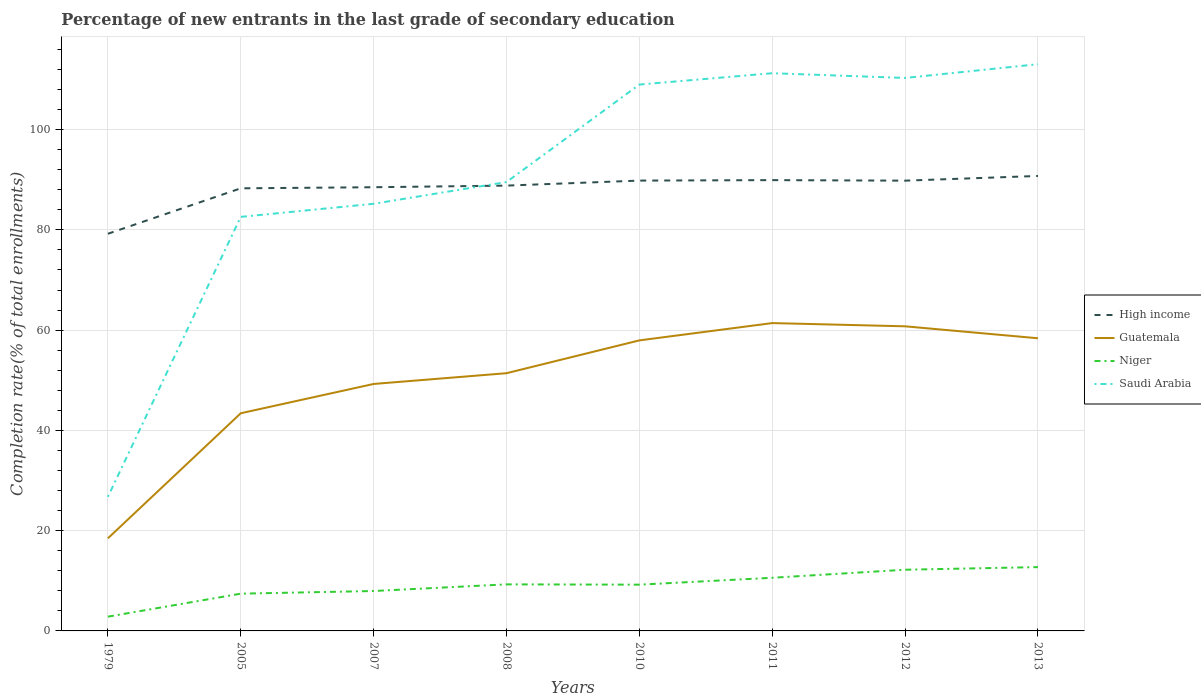Is the number of lines equal to the number of legend labels?
Keep it short and to the point. Yes. Across all years, what is the maximum percentage of new entrants in Saudi Arabia?
Offer a terse response. 26.76. In which year was the percentage of new entrants in Guatemala maximum?
Provide a short and direct response. 1979. What is the total percentage of new entrants in Saudi Arabia in the graph?
Offer a very short reply. -82.22. What is the difference between the highest and the second highest percentage of new entrants in Saudi Arabia?
Keep it short and to the point. 86.28. What is the difference between two consecutive major ticks on the Y-axis?
Make the answer very short. 20. Are the values on the major ticks of Y-axis written in scientific E-notation?
Offer a terse response. No. Does the graph contain grids?
Keep it short and to the point. Yes. How many legend labels are there?
Provide a short and direct response. 4. What is the title of the graph?
Provide a short and direct response. Percentage of new entrants in the last grade of secondary education. What is the label or title of the Y-axis?
Ensure brevity in your answer.  Completion rate(% of total enrollments). What is the Completion rate(% of total enrollments) in High income in 1979?
Offer a terse response. 79.22. What is the Completion rate(% of total enrollments) in Guatemala in 1979?
Keep it short and to the point. 18.47. What is the Completion rate(% of total enrollments) of Niger in 1979?
Make the answer very short. 2.85. What is the Completion rate(% of total enrollments) in Saudi Arabia in 1979?
Offer a terse response. 26.76. What is the Completion rate(% of total enrollments) in High income in 2005?
Your response must be concise. 88.28. What is the Completion rate(% of total enrollments) of Guatemala in 2005?
Keep it short and to the point. 43.42. What is the Completion rate(% of total enrollments) in Niger in 2005?
Provide a short and direct response. 7.43. What is the Completion rate(% of total enrollments) of Saudi Arabia in 2005?
Provide a succinct answer. 82.59. What is the Completion rate(% of total enrollments) of High income in 2007?
Your answer should be compact. 88.5. What is the Completion rate(% of total enrollments) in Guatemala in 2007?
Make the answer very short. 49.26. What is the Completion rate(% of total enrollments) in Niger in 2007?
Your answer should be very brief. 7.96. What is the Completion rate(% of total enrollments) in Saudi Arabia in 2007?
Your answer should be compact. 85.2. What is the Completion rate(% of total enrollments) in High income in 2008?
Keep it short and to the point. 88.82. What is the Completion rate(% of total enrollments) in Guatemala in 2008?
Keep it short and to the point. 51.41. What is the Completion rate(% of total enrollments) of Niger in 2008?
Ensure brevity in your answer.  9.29. What is the Completion rate(% of total enrollments) of Saudi Arabia in 2008?
Offer a terse response. 89.53. What is the Completion rate(% of total enrollments) in High income in 2010?
Make the answer very short. 89.82. What is the Completion rate(% of total enrollments) of Guatemala in 2010?
Offer a terse response. 57.95. What is the Completion rate(% of total enrollments) in Niger in 2010?
Provide a short and direct response. 9.23. What is the Completion rate(% of total enrollments) of Saudi Arabia in 2010?
Make the answer very short. 108.98. What is the Completion rate(% of total enrollments) of High income in 2011?
Offer a very short reply. 89.92. What is the Completion rate(% of total enrollments) of Guatemala in 2011?
Offer a very short reply. 61.4. What is the Completion rate(% of total enrollments) of Niger in 2011?
Make the answer very short. 10.6. What is the Completion rate(% of total enrollments) of Saudi Arabia in 2011?
Offer a very short reply. 111.24. What is the Completion rate(% of total enrollments) of High income in 2012?
Offer a terse response. 89.81. What is the Completion rate(% of total enrollments) of Guatemala in 2012?
Give a very brief answer. 60.76. What is the Completion rate(% of total enrollments) of Niger in 2012?
Ensure brevity in your answer.  12.21. What is the Completion rate(% of total enrollments) in Saudi Arabia in 2012?
Your response must be concise. 110.3. What is the Completion rate(% of total enrollments) in High income in 2013?
Your answer should be compact. 90.75. What is the Completion rate(% of total enrollments) of Guatemala in 2013?
Give a very brief answer. 58.37. What is the Completion rate(% of total enrollments) in Niger in 2013?
Make the answer very short. 12.73. What is the Completion rate(% of total enrollments) in Saudi Arabia in 2013?
Your answer should be compact. 113.04. Across all years, what is the maximum Completion rate(% of total enrollments) of High income?
Provide a short and direct response. 90.75. Across all years, what is the maximum Completion rate(% of total enrollments) of Guatemala?
Keep it short and to the point. 61.4. Across all years, what is the maximum Completion rate(% of total enrollments) of Niger?
Keep it short and to the point. 12.73. Across all years, what is the maximum Completion rate(% of total enrollments) in Saudi Arabia?
Your answer should be compact. 113.04. Across all years, what is the minimum Completion rate(% of total enrollments) of High income?
Provide a succinct answer. 79.22. Across all years, what is the minimum Completion rate(% of total enrollments) of Guatemala?
Offer a terse response. 18.47. Across all years, what is the minimum Completion rate(% of total enrollments) of Niger?
Offer a very short reply. 2.85. Across all years, what is the minimum Completion rate(% of total enrollments) in Saudi Arabia?
Give a very brief answer. 26.76. What is the total Completion rate(% of total enrollments) of High income in the graph?
Your answer should be compact. 705.13. What is the total Completion rate(% of total enrollments) in Guatemala in the graph?
Give a very brief answer. 401.04. What is the total Completion rate(% of total enrollments) of Niger in the graph?
Give a very brief answer. 72.29. What is the total Completion rate(% of total enrollments) in Saudi Arabia in the graph?
Your answer should be compact. 727.63. What is the difference between the Completion rate(% of total enrollments) in High income in 1979 and that in 2005?
Provide a succinct answer. -9.06. What is the difference between the Completion rate(% of total enrollments) of Guatemala in 1979 and that in 2005?
Offer a very short reply. -24.95. What is the difference between the Completion rate(% of total enrollments) of Niger in 1979 and that in 2005?
Keep it short and to the point. -4.59. What is the difference between the Completion rate(% of total enrollments) in Saudi Arabia in 1979 and that in 2005?
Provide a short and direct response. -55.83. What is the difference between the Completion rate(% of total enrollments) in High income in 1979 and that in 2007?
Give a very brief answer. -9.28. What is the difference between the Completion rate(% of total enrollments) in Guatemala in 1979 and that in 2007?
Make the answer very short. -30.79. What is the difference between the Completion rate(% of total enrollments) of Niger in 1979 and that in 2007?
Offer a terse response. -5.12. What is the difference between the Completion rate(% of total enrollments) of Saudi Arabia in 1979 and that in 2007?
Your answer should be compact. -58.44. What is the difference between the Completion rate(% of total enrollments) in High income in 1979 and that in 2008?
Your response must be concise. -9.6. What is the difference between the Completion rate(% of total enrollments) in Guatemala in 1979 and that in 2008?
Provide a succinct answer. -32.93. What is the difference between the Completion rate(% of total enrollments) of Niger in 1979 and that in 2008?
Offer a very short reply. -6.44. What is the difference between the Completion rate(% of total enrollments) of Saudi Arabia in 1979 and that in 2008?
Keep it short and to the point. -62.77. What is the difference between the Completion rate(% of total enrollments) in High income in 1979 and that in 2010?
Offer a terse response. -10.6. What is the difference between the Completion rate(% of total enrollments) of Guatemala in 1979 and that in 2010?
Ensure brevity in your answer.  -39.48. What is the difference between the Completion rate(% of total enrollments) of Niger in 1979 and that in 2010?
Give a very brief answer. -6.38. What is the difference between the Completion rate(% of total enrollments) of Saudi Arabia in 1979 and that in 2010?
Offer a terse response. -82.22. What is the difference between the Completion rate(% of total enrollments) in High income in 1979 and that in 2011?
Offer a very short reply. -10.7. What is the difference between the Completion rate(% of total enrollments) in Guatemala in 1979 and that in 2011?
Provide a short and direct response. -42.93. What is the difference between the Completion rate(% of total enrollments) of Niger in 1979 and that in 2011?
Your answer should be compact. -7.76. What is the difference between the Completion rate(% of total enrollments) in Saudi Arabia in 1979 and that in 2011?
Offer a very short reply. -84.48. What is the difference between the Completion rate(% of total enrollments) in High income in 1979 and that in 2012?
Offer a very short reply. -10.59. What is the difference between the Completion rate(% of total enrollments) of Guatemala in 1979 and that in 2012?
Provide a succinct answer. -42.29. What is the difference between the Completion rate(% of total enrollments) in Niger in 1979 and that in 2012?
Your answer should be very brief. -9.36. What is the difference between the Completion rate(% of total enrollments) in Saudi Arabia in 1979 and that in 2012?
Your response must be concise. -83.54. What is the difference between the Completion rate(% of total enrollments) in High income in 1979 and that in 2013?
Offer a terse response. -11.53. What is the difference between the Completion rate(% of total enrollments) of Guatemala in 1979 and that in 2013?
Ensure brevity in your answer.  -39.9. What is the difference between the Completion rate(% of total enrollments) in Niger in 1979 and that in 2013?
Your answer should be very brief. -9.88. What is the difference between the Completion rate(% of total enrollments) in Saudi Arabia in 1979 and that in 2013?
Ensure brevity in your answer.  -86.28. What is the difference between the Completion rate(% of total enrollments) in High income in 2005 and that in 2007?
Keep it short and to the point. -0.22. What is the difference between the Completion rate(% of total enrollments) of Guatemala in 2005 and that in 2007?
Ensure brevity in your answer.  -5.84. What is the difference between the Completion rate(% of total enrollments) in Niger in 2005 and that in 2007?
Provide a short and direct response. -0.53. What is the difference between the Completion rate(% of total enrollments) of Saudi Arabia in 2005 and that in 2007?
Provide a succinct answer. -2.61. What is the difference between the Completion rate(% of total enrollments) in High income in 2005 and that in 2008?
Provide a succinct answer. -0.54. What is the difference between the Completion rate(% of total enrollments) in Guatemala in 2005 and that in 2008?
Make the answer very short. -7.99. What is the difference between the Completion rate(% of total enrollments) in Niger in 2005 and that in 2008?
Provide a short and direct response. -1.85. What is the difference between the Completion rate(% of total enrollments) of Saudi Arabia in 2005 and that in 2008?
Provide a short and direct response. -6.95. What is the difference between the Completion rate(% of total enrollments) in High income in 2005 and that in 2010?
Ensure brevity in your answer.  -1.54. What is the difference between the Completion rate(% of total enrollments) in Guatemala in 2005 and that in 2010?
Make the answer very short. -14.53. What is the difference between the Completion rate(% of total enrollments) of Niger in 2005 and that in 2010?
Ensure brevity in your answer.  -1.8. What is the difference between the Completion rate(% of total enrollments) in Saudi Arabia in 2005 and that in 2010?
Provide a short and direct response. -26.39. What is the difference between the Completion rate(% of total enrollments) in High income in 2005 and that in 2011?
Provide a succinct answer. -1.63. What is the difference between the Completion rate(% of total enrollments) in Guatemala in 2005 and that in 2011?
Offer a very short reply. -17.99. What is the difference between the Completion rate(% of total enrollments) in Niger in 2005 and that in 2011?
Your answer should be compact. -3.17. What is the difference between the Completion rate(% of total enrollments) in Saudi Arabia in 2005 and that in 2011?
Keep it short and to the point. -28.65. What is the difference between the Completion rate(% of total enrollments) in High income in 2005 and that in 2012?
Make the answer very short. -1.53. What is the difference between the Completion rate(% of total enrollments) in Guatemala in 2005 and that in 2012?
Provide a short and direct response. -17.34. What is the difference between the Completion rate(% of total enrollments) of Niger in 2005 and that in 2012?
Offer a very short reply. -4.78. What is the difference between the Completion rate(% of total enrollments) in Saudi Arabia in 2005 and that in 2012?
Keep it short and to the point. -27.71. What is the difference between the Completion rate(% of total enrollments) in High income in 2005 and that in 2013?
Give a very brief answer. -2.47. What is the difference between the Completion rate(% of total enrollments) in Guatemala in 2005 and that in 2013?
Ensure brevity in your answer.  -14.96. What is the difference between the Completion rate(% of total enrollments) of Niger in 2005 and that in 2013?
Your answer should be very brief. -5.3. What is the difference between the Completion rate(% of total enrollments) in Saudi Arabia in 2005 and that in 2013?
Ensure brevity in your answer.  -30.45. What is the difference between the Completion rate(% of total enrollments) of High income in 2007 and that in 2008?
Provide a succinct answer. -0.32. What is the difference between the Completion rate(% of total enrollments) in Guatemala in 2007 and that in 2008?
Make the answer very short. -2.15. What is the difference between the Completion rate(% of total enrollments) in Niger in 2007 and that in 2008?
Give a very brief answer. -1.32. What is the difference between the Completion rate(% of total enrollments) of Saudi Arabia in 2007 and that in 2008?
Make the answer very short. -4.33. What is the difference between the Completion rate(% of total enrollments) of High income in 2007 and that in 2010?
Keep it short and to the point. -1.32. What is the difference between the Completion rate(% of total enrollments) in Guatemala in 2007 and that in 2010?
Ensure brevity in your answer.  -8.69. What is the difference between the Completion rate(% of total enrollments) of Niger in 2007 and that in 2010?
Provide a short and direct response. -1.27. What is the difference between the Completion rate(% of total enrollments) of Saudi Arabia in 2007 and that in 2010?
Your response must be concise. -23.78. What is the difference between the Completion rate(% of total enrollments) in High income in 2007 and that in 2011?
Offer a very short reply. -1.42. What is the difference between the Completion rate(% of total enrollments) in Guatemala in 2007 and that in 2011?
Your answer should be very brief. -12.14. What is the difference between the Completion rate(% of total enrollments) in Niger in 2007 and that in 2011?
Your answer should be compact. -2.64. What is the difference between the Completion rate(% of total enrollments) in Saudi Arabia in 2007 and that in 2011?
Make the answer very short. -26.04. What is the difference between the Completion rate(% of total enrollments) of High income in 2007 and that in 2012?
Provide a short and direct response. -1.31. What is the difference between the Completion rate(% of total enrollments) in Guatemala in 2007 and that in 2012?
Your answer should be compact. -11.5. What is the difference between the Completion rate(% of total enrollments) in Niger in 2007 and that in 2012?
Offer a terse response. -4.24. What is the difference between the Completion rate(% of total enrollments) in Saudi Arabia in 2007 and that in 2012?
Keep it short and to the point. -25.1. What is the difference between the Completion rate(% of total enrollments) in High income in 2007 and that in 2013?
Provide a succinct answer. -2.25. What is the difference between the Completion rate(% of total enrollments) of Guatemala in 2007 and that in 2013?
Your answer should be very brief. -9.11. What is the difference between the Completion rate(% of total enrollments) of Niger in 2007 and that in 2013?
Provide a succinct answer. -4.77. What is the difference between the Completion rate(% of total enrollments) in Saudi Arabia in 2007 and that in 2013?
Give a very brief answer. -27.84. What is the difference between the Completion rate(% of total enrollments) of High income in 2008 and that in 2010?
Ensure brevity in your answer.  -1. What is the difference between the Completion rate(% of total enrollments) of Guatemala in 2008 and that in 2010?
Ensure brevity in your answer.  -6.55. What is the difference between the Completion rate(% of total enrollments) in Niger in 2008 and that in 2010?
Your answer should be very brief. 0.06. What is the difference between the Completion rate(% of total enrollments) in Saudi Arabia in 2008 and that in 2010?
Offer a terse response. -19.44. What is the difference between the Completion rate(% of total enrollments) in High income in 2008 and that in 2011?
Make the answer very short. -1.09. What is the difference between the Completion rate(% of total enrollments) of Guatemala in 2008 and that in 2011?
Your response must be concise. -10. What is the difference between the Completion rate(% of total enrollments) of Niger in 2008 and that in 2011?
Ensure brevity in your answer.  -1.32. What is the difference between the Completion rate(% of total enrollments) of Saudi Arabia in 2008 and that in 2011?
Provide a short and direct response. -21.71. What is the difference between the Completion rate(% of total enrollments) in High income in 2008 and that in 2012?
Provide a short and direct response. -0.99. What is the difference between the Completion rate(% of total enrollments) of Guatemala in 2008 and that in 2012?
Make the answer very short. -9.35. What is the difference between the Completion rate(% of total enrollments) in Niger in 2008 and that in 2012?
Provide a succinct answer. -2.92. What is the difference between the Completion rate(% of total enrollments) in Saudi Arabia in 2008 and that in 2012?
Offer a terse response. -20.77. What is the difference between the Completion rate(% of total enrollments) in High income in 2008 and that in 2013?
Give a very brief answer. -1.93. What is the difference between the Completion rate(% of total enrollments) in Guatemala in 2008 and that in 2013?
Provide a short and direct response. -6.97. What is the difference between the Completion rate(% of total enrollments) in Niger in 2008 and that in 2013?
Your answer should be very brief. -3.44. What is the difference between the Completion rate(% of total enrollments) of Saudi Arabia in 2008 and that in 2013?
Keep it short and to the point. -23.51. What is the difference between the Completion rate(% of total enrollments) of High income in 2010 and that in 2011?
Provide a short and direct response. -0.09. What is the difference between the Completion rate(% of total enrollments) in Guatemala in 2010 and that in 2011?
Make the answer very short. -3.45. What is the difference between the Completion rate(% of total enrollments) of Niger in 2010 and that in 2011?
Your answer should be very brief. -1.37. What is the difference between the Completion rate(% of total enrollments) of Saudi Arabia in 2010 and that in 2011?
Your answer should be very brief. -2.27. What is the difference between the Completion rate(% of total enrollments) of High income in 2010 and that in 2012?
Your answer should be compact. 0.01. What is the difference between the Completion rate(% of total enrollments) in Guatemala in 2010 and that in 2012?
Your response must be concise. -2.81. What is the difference between the Completion rate(% of total enrollments) in Niger in 2010 and that in 2012?
Your answer should be very brief. -2.98. What is the difference between the Completion rate(% of total enrollments) of Saudi Arabia in 2010 and that in 2012?
Provide a succinct answer. -1.32. What is the difference between the Completion rate(% of total enrollments) of High income in 2010 and that in 2013?
Provide a short and direct response. -0.93. What is the difference between the Completion rate(% of total enrollments) in Guatemala in 2010 and that in 2013?
Your answer should be compact. -0.42. What is the difference between the Completion rate(% of total enrollments) of Niger in 2010 and that in 2013?
Offer a very short reply. -3.5. What is the difference between the Completion rate(% of total enrollments) in Saudi Arabia in 2010 and that in 2013?
Your answer should be very brief. -4.06. What is the difference between the Completion rate(% of total enrollments) in High income in 2011 and that in 2012?
Your answer should be very brief. 0.11. What is the difference between the Completion rate(% of total enrollments) in Guatemala in 2011 and that in 2012?
Your answer should be very brief. 0.64. What is the difference between the Completion rate(% of total enrollments) in Niger in 2011 and that in 2012?
Make the answer very short. -1.6. What is the difference between the Completion rate(% of total enrollments) in Saudi Arabia in 2011 and that in 2012?
Keep it short and to the point. 0.94. What is the difference between the Completion rate(% of total enrollments) in High income in 2011 and that in 2013?
Keep it short and to the point. -0.83. What is the difference between the Completion rate(% of total enrollments) in Guatemala in 2011 and that in 2013?
Ensure brevity in your answer.  3.03. What is the difference between the Completion rate(% of total enrollments) in Niger in 2011 and that in 2013?
Your answer should be compact. -2.13. What is the difference between the Completion rate(% of total enrollments) of Saudi Arabia in 2011 and that in 2013?
Ensure brevity in your answer.  -1.8. What is the difference between the Completion rate(% of total enrollments) of High income in 2012 and that in 2013?
Provide a succinct answer. -0.94. What is the difference between the Completion rate(% of total enrollments) of Guatemala in 2012 and that in 2013?
Make the answer very short. 2.38. What is the difference between the Completion rate(% of total enrollments) in Niger in 2012 and that in 2013?
Your answer should be very brief. -0.52. What is the difference between the Completion rate(% of total enrollments) of Saudi Arabia in 2012 and that in 2013?
Your answer should be compact. -2.74. What is the difference between the Completion rate(% of total enrollments) of High income in 1979 and the Completion rate(% of total enrollments) of Guatemala in 2005?
Give a very brief answer. 35.8. What is the difference between the Completion rate(% of total enrollments) of High income in 1979 and the Completion rate(% of total enrollments) of Niger in 2005?
Keep it short and to the point. 71.79. What is the difference between the Completion rate(% of total enrollments) of High income in 1979 and the Completion rate(% of total enrollments) of Saudi Arabia in 2005?
Ensure brevity in your answer.  -3.37. What is the difference between the Completion rate(% of total enrollments) in Guatemala in 1979 and the Completion rate(% of total enrollments) in Niger in 2005?
Offer a terse response. 11.04. What is the difference between the Completion rate(% of total enrollments) of Guatemala in 1979 and the Completion rate(% of total enrollments) of Saudi Arabia in 2005?
Your answer should be compact. -64.12. What is the difference between the Completion rate(% of total enrollments) in Niger in 1979 and the Completion rate(% of total enrollments) in Saudi Arabia in 2005?
Offer a very short reply. -79.74. What is the difference between the Completion rate(% of total enrollments) of High income in 1979 and the Completion rate(% of total enrollments) of Guatemala in 2007?
Your answer should be very brief. 29.96. What is the difference between the Completion rate(% of total enrollments) in High income in 1979 and the Completion rate(% of total enrollments) in Niger in 2007?
Provide a succinct answer. 71.26. What is the difference between the Completion rate(% of total enrollments) of High income in 1979 and the Completion rate(% of total enrollments) of Saudi Arabia in 2007?
Your response must be concise. -5.98. What is the difference between the Completion rate(% of total enrollments) of Guatemala in 1979 and the Completion rate(% of total enrollments) of Niger in 2007?
Keep it short and to the point. 10.51. What is the difference between the Completion rate(% of total enrollments) of Guatemala in 1979 and the Completion rate(% of total enrollments) of Saudi Arabia in 2007?
Make the answer very short. -66.73. What is the difference between the Completion rate(% of total enrollments) of Niger in 1979 and the Completion rate(% of total enrollments) of Saudi Arabia in 2007?
Your answer should be compact. -82.35. What is the difference between the Completion rate(% of total enrollments) in High income in 1979 and the Completion rate(% of total enrollments) in Guatemala in 2008?
Keep it short and to the point. 27.81. What is the difference between the Completion rate(% of total enrollments) of High income in 1979 and the Completion rate(% of total enrollments) of Niger in 2008?
Your response must be concise. 69.93. What is the difference between the Completion rate(% of total enrollments) of High income in 1979 and the Completion rate(% of total enrollments) of Saudi Arabia in 2008?
Provide a succinct answer. -10.31. What is the difference between the Completion rate(% of total enrollments) of Guatemala in 1979 and the Completion rate(% of total enrollments) of Niger in 2008?
Offer a terse response. 9.19. What is the difference between the Completion rate(% of total enrollments) of Guatemala in 1979 and the Completion rate(% of total enrollments) of Saudi Arabia in 2008?
Give a very brief answer. -71.06. What is the difference between the Completion rate(% of total enrollments) of Niger in 1979 and the Completion rate(% of total enrollments) of Saudi Arabia in 2008?
Provide a short and direct response. -86.69. What is the difference between the Completion rate(% of total enrollments) in High income in 1979 and the Completion rate(% of total enrollments) in Guatemala in 2010?
Make the answer very short. 21.27. What is the difference between the Completion rate(% of total enrollments) of High income in 1979 and the Completion rate(% of total enrollments) of Niger in 2010?
Your answer should be very brief. 69.99. What is the difference between the Completion rate(% of total enrollments) in High income in 1979 and the Completion rate(% of total enrollments) in Saudi Arabia in 2010?
Your answer should be very brief. -29.76. What is the difference between the Completion rate(% of total enrollments) of Guatemala in 1979 and the Completion rate(% of total enrollments) of Niger in 2010?
Ensure brevity in your answer.  9.24. What is the difference between the Completion rate(% of total enrollments) in Guatemala in 1979 and the Completion rate(% of total enrollments) in Saudi Arabia in 2010?
Offer a terse response. -90.5. What is the difference between the Completion rate(% of total enrollments) in Niger in 1979 and the Completion rate(% of total enrollments) in Saudi Arabia in 2010?
Provide a short and direct response. -106.13. What is the difference between the Completion rate(% of total enrollments) in High income in 1979 and the Completion rate(% of total enrollments) in Guatemala in 2011?
Give a very brief answer. 17.82. What is the difference between the Completion rate(% of total enrollments) in High income in 1979 and the Completion rate(% of total enrollments) in Niger in 2011?
Give a very brief answer. 68.62. What is the difference between the Completion rate(% of total enrollments) in High income in 1979 and the Completion rate(% of total enrollments) in Saudi Arabia in 2011?
Your response must be concise. -32.02. What is the difference between the Completion rate(% of total enrollments) of Guatemala in 1979 and the Completion rate(% of total enrollments) of Niger in 2011?
Your answer should be very brief. 7.87. What is the difference between the Completion rate(% of total enrollments) of Guatemala in 1979 and the Completion rate(% of total enrollments) of Saudi Arabia in 2011?
Keep it short and to the point. -92.77. What is the difference between the Completion rate(% of total enrollments) of Niger in 1979 and the Completion rate(% of total enrollments) of Saudi Arabia in 2011?
Ensure brevity in your answer.  -108.4. What is the difference between the Completion rate(% of total enrollments) in High income in 1979 and the Completion rate(% of total enrollments) in Guatemala in 2012?
Offer a terse response. 18.46. What is the difference between the Completion rate(% of total enrollments) of High income in 1979 and the Completion rate(% of total enrollments) of Niger in 2012?
Offer a terse response. 67.01. What is the difference between the Completion rate(% of total enrollments) of High income in 1979 and the Completion rate(% of total enrollments) of Saudi Arabia in 2012?
Offer a very short reply. -31.08. What is the difference between the Completion rate(% of total enrollments) of Guatemala in 1979 and the Completion rate(% of total enrollments) of Niger in 2012?
Keep it short and to the point. 6.27. What is the difference between the Completion rate(% of total enrollments) in Guatemala in 1979 and the Completion rate(% of total enrollments) in Saudi Arabia in 2012?
Ensure brevity in your answer.  -91.83. What is the difference between the Completion rate(% of total enrollments) of Niger in 1979 and the Completion rate(% of total enrollments) of Saudi Arabia in 2012?
Give a very brief answer. -107.45. What is the difference between the Completion rate(% of total enrollments) in High income in 1979 and the Completion rate(% of total enrollments) in Guatemala in 2013?
Provide a succinct answer. 20.85. What is the difference between the Completion rate(% of total enrollments) of High income in 1979 and the Completion rate(% of total enrollments) of Niger in 2013?
Provide a short and direct response. 66.49. What is the difference between the Completion rate(% of total enrollments) of High income in 1979 and the Completion rate(% of total enrollments) of Saudi Arabia in 2013?
Provide a succinct answer. -33.82. What is the difference between the Completion rate(% of total enrollments) of Guatemala in 1979 and the Completion rate(% of total enrollments) of Niger in 2013?
Your answer should be very brief. 5.74. What is the difference between the Completion rate(% of total enrollments) in Guatemala in 1979 and the Completion rate(% of total enrollments) in Saudi Arabia in 2013?
Your response must be concise. -94.57. What is the difference between the Completion rate(% of total enrollments) in Niger in 1979 and the Completion rate(% of total enrollments) in Saudi Arabia in 2013?
Offer a very short reply. -110.19. What is the difference between the Completion rate(% of total enrollments) in High income in 2005 and the Completion rate(% of total enrollments) in Guatemala in 2007?
Keep it short and to the point. 39.02. What is the difference between the Completion rate(% of total enrollments) of High income in 2005 and the Completion rate(% of total enrollments) of Niger in 2007?
Make the answer very short. 80.32. What is the difference between the Completion rate(% of total enrollments) in High income in 2005 and the Completion rate(% of total enrollments) in Saudi Arabia in 2007?
Your answer should be compact. 3.08. What is the difference between the Completion rate(% of total enrollments) of Guatemala in 2005 and the Completion rate(% of total enrollments) of Niger in 2007?
Offer a very short reply. 35.46. What is the difference between the Completion rate(% of total enrollments) of Guatemala in 2005 and the Completion rate(% of total enrollments) of Saudi Arabia in 2007?
Keep it short and to the point. -41.78. What is the difference between the Completion rate(% of total enrollments) of Niger in 2005 and the Completion rate(% of total enrollments) of Saudi Arabia in 2007?
Provide a succinct answer. -77.77. What is the difference between the Completion rate(% of total enrollments) in High income in 2005 and the Completion rate(% of total enrollments) in Guatemala in 2008?
Your response must be concise. 36.88. What is the difference between the Completion rate(% of total enrollments) of High income in 2005 and the Completion rate(% of total enrollments) of Niger in 2008?
Provide a short and direct response. 79. What is the difference between the Completion rate(% of total enrollments) of High income in 2005 and the Completion rate(% of total enrollments) of Saudi Arabia in 2008?
Offer a very short reply. -1.25. What is the difference between the Completion rate(% of total enrollments) of Guatemala in 2005 and the Completion rate(% of total enrollments) of Niger in 2008?
Your answer should be very brief. 34.13. What is the difference between the Completion rate(% of total enrollments) of Guatemala in 2005 and the Completion rate(% of total enrollments) of Saudi Arabia in 2008?
Give a very brief answer. -46.12. What is the difference between the Completion rate(% of total enrollments) in Niger in 2005 and the Completion rate(% of total enrollments) in Saudi Arabia in 2008?
Your answer should be very brief. -82.1. What is the difference between the Completion rate(% of total enrollments) in High income in 2005 and the Completion rate(% of total enrollments) in Guatemala in 2010?
Keep it short and to the point. 30.33. What is the difference between the Completion rate(% of total enrollments) in High income in 2005 and the Completion rate(% of total enrollments) in Niger in 2010?
Offer a terse response. 79.06. What is the difference between the Completion rate(% of total enrollments) of High income in 2005 and the Completion rate(% of total enrollments) of Saudi Arabia in 2010?
Your response must be concise. -20.69. What is the difference between the Completion rate(% of total enrollments) in Guatemala in 2005 and the Completion rate(% of total enrollments) in Niger in 2010?
Ensure brevity in your answer.  34.19. What is the difference between the Completion rate(% of total enrollments) of Guatemala in 2005 and the Completion rate(% of total enrollments) of Saudi Arabia in 2010?
Offer a terse response. -65.56. What is the difference between the Completion rate(% of total enrollments) of Niger in 2005 and the Completion rate(% of total enrollments) of Saudi Arabia in 2010?
Your answer should be compact. -101.54. What is the difference between the Completion rate(% of total enrollments) of High income in 2005 and the Completion rate(% of total enrollments) of Guatemala in 2011?
Your response must be concise. 26.88. What is the difference between the Completion rate(% of total enrollments) of High income in 2005 and the Completion rate(% of total enrollments) of Niger in 2011?
Offer a terse response. 77.68. What is the difference between the Completion rate(% of total enrollments) of High income in 2005 and the Completion rate(% of total enrollments) of Saudi Arabia in 2011?
Offer a very short reply. -22.96. What is the difference between the Completion rate(% of total enrollments) in Guatemala in 2005 and the Completion rate(% of total enrollments) in Niger in 2011?
Offer a very short reply. 32.82. What is the difference between the Completion rate(% of total enrollments) in Guatemala in 2005 and the Completion rate(% of total enrollments) in Saudi Arabia in 2011?
Your answer should be compact. -67.82. What is the difference between the Completion rate(% of total enrollments) of Niger in 2005 and the Completion rate(% of total enrollments) of Saudi Arabia in 2011?
Ensure brevity in your answer.  -103.81. What is the difference between the Completion rate(% of total enrollments) in High income in 2005 and the Completion rate(% of total enrollments) in Guatemala in 2012?
Ensure brevity in your answer.  27.53. What is the difference between the Completion rate(% of total enrollments) in High income in 2005 and the Completion rate(% of total enrollments) in Niger in 2012?
Your answer should be very brief. 76.08. What is the difference between the Completion rate(% of total enrollments) of High income in 2005 and the Completion rate(% of total enrollments) of Saudi Arabia in 2012?
Offer a very short reply. -22.01. What is the difference between the Completion rate(% of total enrollments) in Guatemala in 2005 and the Completion rate(% of total enrollments) in Niger in 2012?
Offer a very short reply. 31.21. What is the difference between the Completion rate(% of total enrollments) of Guatemala in 2005 and the Completion rate(% of total enrollments) of Saudi Arabia in 2012?
Your answer should be very brief. -66.88. What is the difference between the Completion rate(% of total enrollments) in Niger in 2005 and the Completion rate(% of total enrollments) in Saudi Arabia in 2012?
Give a very brief answer. -102.87. What is the difference between the Completion rate(% of total enrollments) in High income in 2005 and the Completion rate(% of total enrollments) in Guatemala in 2013?
Your answer should be very brief. 29.91. What is the difference between the Completion rate(% of total enrollments) in High income in 2005 and the Completion rate(% of total enrollments) in Niger in 2013?
Provide a succinct answer. 75.56. What is the difference between the Completion rate(% of total enrollments) of High income in 2005 and the Completion rate(% of total enrollments) of Saudi Arabia in 2013?
Offer a very short reply. -24.76. What is the difference between the Completion rate(% of total enrollments) in Guatemala in 2005 and the Completion rate(% of total enrollments) in Niger in 2013?
Keep it short and to the point. 30.69. What is the difference between the Completion rate(% of total enrollments) of Guatemala in 2005 and the Completion rate(% of total enrollments) of Saudi Arabia in 2013?
Keep it short and to the point. -69.62. What is the difference between the Completion rate(% of total enrollments) of Niger in 2005 and the Completion rate(% of total enrollments) of Saudi Arabia in 2013?
Your response must be concise. -105.61. What is the difference between the Completion rate(% of total enrollments) of High income in 2007 and the Completion rate(% of total enrollments) of Guatemala in 2008?
Keep it short and to the point. 37.09. What is the difference between the Completion rate(% of total enrollments) in High income in 2007 and the Completion rate(% of total enrollments) in Niger in 2008?
Ensure brevity in your answer.  79.22. What is the difference between the Completion rate(% of total enrollments) in High income in 2007 and the Completion rate(% of total enrollments) in Saudi Arabia in 2008?
Ensure brevity in your answer.  -1.03. What is the difference between the Completion rate(% of total enrollments) of Guatemala in 2007 and the Completion rate(% of total enrollments) of Niger in 2008?
Make the answer very short. 39.97. What is the difference between the Completion rate(% of total enrollments) of Guatemala in 2007 and the Completion rate(% of total enrollments) of Saudi Arabia in 2008?
Provide a succinct answer. -40.27. What is the difference between the Completion rate(% of total enrollments) of Niger in 2007 and the Completion rate(% of total enrollments) of Saudi Arabia in 2008?
Give a very brief answer. -81.57. What is the difference between the Completion rate(% of total enrollments) in High income in 2007 and the Completion rate(% of total enrollments) in Guatemala in 2010?
Make the answer very short. 30.55. What is the difference between the Completion rate(% of total enrollments) in High income in 2007 and the Completion rate(% of total enrollments) in Niger in 2010?
Your answer should be compact. 79.27. What is the difference between the Completion rate(% of total enrollments) in High income in 2007 and the Completion rate(% of total enrollments) in Saudi Arabia in 2010?
Offer a very short reply. -20.48. What is the difference between the Completion rate(% of total enrollments) of Guatemala in 2007 and the Completion rate(% of total enrollments) of Niger in 2010?
Offer a very short reply. 40.03. What is the difference between the Completion rate(% of total enrollments) in Guatemala in 2007 and the Completion rate(% of total enrollments) in Saudi Arabia in 2010?
Provide a short and direct response. -59.72. What is the difference between the Completion rate(% of total enrollments) in Niger in 2007 and the Completion rate(% of total enrollments) in Saudi Arabia in 2010?
Keep it short and to the point. -101.01. What is the difference between the Completion rate(% of total enrollments) in High income in 2007 and the Completion rate(% of total enrollments) in Guatemala in 2011?
Offer a very short reply. 27.1. What is the difference between the Completion rate(% of total enrollments) of High income in 2007 and the Completion rate(% of total enrollments) of Niger in 2011?
Your response must be concise. 77.9. What is the difference between the Completion rate(% of total enrollments) of High income in 2007 and the Completion rate(% of total enrollments) of Saudi Arabia in 2011?
Give a very brief answer. -22.74. What is the difference between the Completion rate(% of total enrollments) in Guatemala in 2007 and the Completion rate(% of total enrollments) in Niger in 2011?
Your answer should be compact. 38.66. What is the difference between the Completion rate(% of total enrollments) of Guatemala in 2007 and the Completion rate(% of total enrollments) of Saudi Arabia in 2011?
Make the answer very short. -61.98. What is the difference between the Completion rate(% of total enrollments) in Niger in 2007 and the Completion rate(% of total enrollments) in Saudi Arabia in 2011?
Keep it short and to the point. -103.28. What is the difference between the Completion rate(% of total enrollments) of High income in 2007 and the Completion rate(% of total enrollments) of Guatemala in 2012?
Your response must be concise. 27.74. What is the difference between the Completion rate(% of total enrollments) in High income in 2007 and the Completion rate(% of total enrollments) in Niger in 2012?
Offer a very short reply. 76.29. What is the difference between the Completion rate(% of total enrollments) in High income in 2007 and the Completion rate(% of total enrollments) in Saudi Arabia in 2012?
Your answer should be very brief. -21.8. What is the difference between the Completion rate(% of total enrollments) of Guatemala in 2007 and the Completion rate(% of total enrollments) of Niger in 2012?
Your answer should be very brief. 37.05. What is the difference between the Completion rate(% of total enrollments) of Guatemala in 2007 and the Completion rate(% of total enrollments) of Saudi Arabia in 2012?
Your answer should be very brief. -61.04. What is the difference between the Completion rate(% of total enrollments) of Niger in 2007 and the Completion rate(% of total enrollments) of Saudi Arabia in 2012?
Your answer should be compact. -102.34. What is the difference between the Completion rate(% of total enrollments) of High income in 2007 and the Completion rate(% of total enrollments) of Guatemala in 2013?
Offer a very short reply. 30.13. What is the difference between the Completion rate(% of total enrollments) in High income in 2007 and the Completion rate(% of total enrollments) in Niger in 2013?
Give a very brief answer. 75.77. What is the difference between the Completion rate(% of total enrollments) in High income in 2007 and the Completion rate(% of total enrollments) in Saudi Arabia in 2013?
Provide a succinct answer. -24.54. What is the difference between the Completion rate(% of total enrollments) of Guatemala in 2007 and the Completion rate(% of total enrollments) of Niger in 2013?
Offer a very short reply. 36.53. What is the difference between the Completion rate(% of total enrollments) in Guatemala in 2007 and the Completion rate(% of total enrollments) in Saudi Arabia in 2013?
Ensure brevity in your answer.  -63.78. What is the difference between the Completion rate(% of total enrollments) of Niger in 2007 and the Completion rate(% of total enrollments) of Saudi Arabia in 2013?
Provide a succinct answer. -105.08. What is the difference between the Completion rate(% of total enrollments) of High income in 2008 and the Completion rate(% of total enrollments) of Guatemala in 2010?
Provide a short and direct response. 30.87. What is the difference between the Completion rate(% of total enrollments) of High income in 2008 and the Completion rate(% of total enrollments) of Niger in 2010?
Provide a succinct answer. 79.6. What is the difference between the Completion rate(% of total enrollments) of High income in 2008 and the Completion rate(% of total enrollments) of Saudi Arabia in 2010?
Ensure brevity in your answer.  -20.15. What is the difference between the Completion rate(% of total enrollments) of Guatemala in 2008 and the Completion rate(% of total enrollments) of Niger in 2010?
Offer a very short reply. 42.18. What is the difference between the Completion rate(% of total enrollments) in Guatemala in 2008 and the Completion rate(% of total enrollments) in Saudi Arabia in 2010?
Your response must be concise. -57.57. What is the difference between the Completion rate(% of total enrollments) of Niger in 2008 and the Completion rate(% of total enrollments) of Saudi Arabia in 2010?
Make the answer very short. -99.69. What is the difference between the Completion rate(% of total enrollments) in High income in 2008 and the Completion rate(% of total enrollments) in Guatemala in 2011?
Give a very brief answer. 27.42. What is the difference between the Completion rate(% of total enrollments) in High income in 2008 and the Completion rate(% of total enrollments) in Niger in 2011?
Provide a succinct answer. 78.22. What is the difference between the Completion rate(% of total enrollments) of High income in 2008 and the Completion rate(% of total enrollments) of Saudi Arabia in 2011?
Keep it short and to the point. -22.42. What is the difference between the Completion rate(% of total enrollments) in Guatemala in 2008 and the Completion rate(% of total enrollments) in Niger in 2011?
Ensure brevity in your answer.  40.8. What is the difference between the Completion rate(% of total enrollments) of Guatemala in 2008 and the Completion rate(% of total enrollments) of Saudi Arabia in 2011?
Your response must be concise. -59.84. What is the difference between the Completion rate(% of total enrollments) of Niger in 2008 and the Completion rate(% of total enrollments) of Saudi Arabia in 2011?
Your response must be concise. -101.96. What is the difference between the Completion rate(% of total enrollments) of High income in 2008 and the Completion rate(% of total enrollments) of Guatemala in 2012?
Your answer should be very brief. 28.06. What is the difference between the Completion rate(% of total enrollments) in High income in 2008 and the Completion rate(% of total enrollments) in Niger in 2012?
Your response must be concise. 76.62. What is the difference between the Completion rate(% of total enrollments) of High income in 2008 and the Completion rate(% of total enrollments) of Saudi Arabia in 2012?
Your answer should be compact. -21.48. What is the difference between the Completion rate(% of total enrollments) of Guatemala in 2008 and the Completion rate(% of total enrollments) of Niger in 2012?
Your response must be concise. 39.2. What is the difference between the Completion rate(% of total enrollments) of Guatemala in 2008 and the Completion rate(% of total enrollments) of Saudi Arabia in 2012?
Your answer should be very brief. -58.89. What is the difference between the Completion rate(% of total enrollments) of Niger in 2008 and the Completion rate(% of total enrollments) of Saudi Arabia in 2012?
Make the answer very short. -101.01. What is the difference between the Completion rate(% of total enrollments) in High income in 2008 and the Completion rate(% of total enrollments) in Guatemala in 2013?
Provide a succinct answer. 30.45. What is the difference between the Completion rate(% of total enrollments) in High income in 2008 and the Completion rate(% of total enrollments) in Niger in 2013?
Keep it short and to the point. 76.09. What is the difference between the Completion rate(% of total enrollments) of High income in 2008 and the Completion rate(% of total enrollments) of Saudi Arabia in 2013?
Your response must be concise. -24.22. What is the difference between the Completion rate(% of total enrollments) of Guatemala in 2008 and the Completion rate(% of total enrollments) of Niger in 2013?
Keep it short and to the point. 38.68. What is the difference between the Completion rate(% of total enrollments) of Guatemala in 2008 and the Completion rate(% of total enrollments) of Saudi Arabia in 2013?
Keep it short and to the point. -61.63. What is the difference between the Completion rate(% of total enrollments) in Niger in 2008 and the Completion rate(% of total enrollments) in Saudi Arabia in 2013?
Provide a succinct answer. -103.75. What is the difference between the Completion rate(% of total enrollments) in High income in 2010 and the Completion rate(% of total enrollments) in Guatemala in 2011?
Give a very brief answer. 28.42. What is the difference between the Completion rate(% of total enrollments) of High income in 2010 and the Completion rate(% of total enrollments) of Niger in 2011?
Keep it short and to the point. 79.22. What is the difference between the Completion rate(% of total enrollments) in High income in 2010 and the Completion rate(% of total enrollments) in Saudi Arabia in 2011?
Give a very brief answer. -21.42. What is the difference between the Completion rate(% of total enrollments) in Guatemala in 2010 and the Completion rate(% of total enrollments) in Niger in 2011?
Provide a short and direct response. 47.35. What is the difference between the Completion rate(% of total enrollments) of Guatemala in 2010 and the Completion rate(% of total enrollments) of Saudi Arabia in 2011?
Keep it short and to the point. -53.29. What is the difference between the Completion rate(% of total enrollments) of Niger in 2010 and the Completion rate(% of total enrollments) of Saudi Arabia in 2011?
Ensure brevity in your answer.  -102.01. What is the difference between the Completion rate(% of total enrollments) of High income in 2010 and the Completion rate(% of total enrollments) of Guatemala in 2012?
Keep it short and to the point. 29.07. What is the difference between the Completion rate(% of total enrollments) in High income in 2010 and the Completion rate(% of total enrollments) in Niger in 2012?
Make the answer very short. 77.62. What is the difference between the Completion rate(% of total enrollments) in High income in 2010 and the Completion rate(% of total enrollments) in Saudi Arabia in 2012?
Give a very brief answer. -20.47. What is the difference between the Completion rate(% of total enrollments) of Guatemala in 2010 and the Completion rate(% of total enrollments) of Niger in 2012?
Offer a very short reply. 45.75. What is the difference between the Completion rate(% of total enrollments) in Guatemala in 2010 and the Completion rate(% of total enrollments) in Saudi Arabia in 2012?
Provide a short and direct response. -52.35. What is the difference between the Completion rate(% of total enrollments) of Niger in 2010 and the Completion rate(% of total enrollments) of Saudi Arabia in 2012?
Your answer should be compact. -101.07. What is the difference between the Completion rate(% of total enrollments) in High income in 2010 and the Completion rate(% of total enrollments) in Guatemala in 2013?
Provide a succinct answer. 31.45. What is the difference between the Completion rate(% of total enrollments) of High income in 2010 and the Completion rate(% of total enrollments) of Niger in 2013?
Your answer should be compact. 77.1. What is the difference between the Completion rate(% of total enrollments) in High income in 2010 and the Completion rate(% of total enrollments) in Saudi Arabia in 2013?
Offer a terse response. -23.22. What is the difference between the Completion rate(% of total enrollments) of Guatemala in 2010 and the Completion rate(% of total enrollments) of Niger in 2013?
Provide a succinct answer. 45.22. What is the difference between the Completion rate(% of total enrollments) of Guatemala in 2010 and the Completion rate(% of total enrollments) of Saudi Arabia in 2013?
Ensure brevity in your answer.  -55.09. What is the difference between the Completion rate(% of total enrollments) of Niger in 2010 and the Completion rate(% of total enrollments) of Saudi Arabia in 2013?
Provide a succinct answer. -103.81. What is the difference between the Completion rate(% of total enrollments) of High income in 2011 and the Completion rate(% of total enrollments) of Guatemala in 2012?
Make the answer very short. 29.16. What is the difference between the Completion rate(% of total enrollments) of High income in 2011 and the Completion rate(% of total enrollments) of Niger in 2012?
Your answer should be very brief. 77.71. What is the difference between the Completion rate(% of total enrollments) of High income in 2011 and the Completion rate(% of total enrollments) of Saudi Arabia in 2012?
Your response must be concise. -20.38. What is the difference between the Completion rate(% of total enrollments) of Guatemala in 2011 and the Completion rate(% of total enrollments) of Niger in 2012?
Offer a terse response. 49.2. What is the difference between the Completion rate(% of total enrollments) in Guatemala in 2011 and the Completion rate(% of total enrollments) in Saudi Arabia in 2012?
Give a very brief answer. -48.9. What is the difference between the Completion rate(% of total enrollments) of Niger in 2011 and the Completion rate(% of total enrollments) of Saudi Arabia in 2012?
Offer a terse response. -99.7. What is the difference between the Completion rate(% of total enrollments) of High income in 2011 and the Completion rate(% of total enrollments) of Guatemala in 2013?
Offer a terse response. 31.54. What is the difference between the Completion rate(% of total enrollments) in High income in 2011 and the Completion rate(% of total enrollments) in Niger in 2013?
Your response must be concise. 77.19. What is the difference between the Completion rate(% of total enrollments) in High income in 2011 and the Completion rate(% of total enrollments) in Saudi Arabia in 2013?
Provide a succinct answer. -23.12. What is the difference between the Completion rate(% of total enrollments) of Guatemala in 2011 and the Completion rate(% of total enrollments) of Niger in 2013?
Offer a terse response. 48.67. What is the difference between the Completion rate(% of total enrollments) in Guatemala in 2011 and the Completion rate(% of total enrollments) in Saudi Arabia in 2013?
Make the answer very short. -51.64. What is the difference between the Completion rate(% of total enrollments) in Niger in 2011 and the Completion rate(% of total enrollments) in Saudi Arabia in 2013?
Provide a succinct answer. -102.44. What is the difference between the Completion rate(% of total enrollments) in High income in 2012 and the Completion rate(% of total enrollments) in Guatemala in 2013?
Your answer should be very brief. 31.44. What is the difference between the Completion rate(% of total enrollments) of High income in 2012 and the Completion rate(% of total enrollments) of Niger in 2013?
Offer a very short reply. 77.08. What is the difference between the Completion rate(% of total enrollments) in High income in 2012 and the Completion rate(% of total enrollments) in Saudi Arabia in 2013?
Your response must be concise. -23.23. What is the difference between the Completion rate(% of total enrollments) in Guatemala in 2012 and the Completion rate(% of total enrollments) in Niger in 2013?
Ensure brevity in your answer.  48.03. What is the difference between the Completion rate(% of total enrollments) in Guatemala in 2012 and the Completion rate(% of total enrollments) in Saudi Arabia in 2013?
Provide a short and direct response. -52.28. What is the difference between the Completion rate(% of total enrollments) of Niger in 2012 and the Completion rate(% of total enrollments) of Saudi Arabia in 2013?
Offer a very short reply. -100.83. What is the average Completion rate(% of total enrollments) of High income per year?
Keep it short and to the point. 88.14. What is the average Completion rate(% of total enrollments) in Guatemala per year?
Provide a succinct answer. 50.13. What is the average Completion rate(% of total enrollments) of Niger per year?
Offer a terse response. 9.04. What is the average Completion rate(% of total enrollments) of Saudi Arabia per year?
Provide a succinct answer. 90.95. In the year 1979, what is the difference between the Completion rate(% of total enrollments) of High income and Completion rate(% of total enrollments) of Guatemala?
Ensure brevity in your answer.  60.75. In the year 1979, what is the difference between the Completion rate(% of total enrollments) of High income and Completion rate(% of total enrollments) of Niger?
Your answer should be very brief. 76.37. In the year 1979, what is the difference between the Completion rate(% of total enrollments) in High income and Completion rate(% of total enrollments) in Saudi Arabia?
Keep it short and to the point. 52.46. In the year 1979, what is the difference between the Completion rate(% of total enrollments) of Guatemala and Completion rate(% of total enrollments) of Niger?
Your answer should be very brief. 15.63. In the year 1979, what is the difference between the Completion rate(% of total enrollments) in Guatemala and Completion rate(% of total enrollments) in Saudi Arabia?
Offer a very short reply. -8.29. In the year 1979, what is the difference between the Completion rate(% of total enrollments) of Niger and Completion rate(% of total enrollments) of Saudi Arabia?
Offer a terse response. -23.91. In the year 2005, what is the difference between the Completion rate(% of total enrollments) in High income and Completion rate(% of total enrollments) in Guatemala?
Make the answer very short. 44.87. In the year 2005, what is the difference between the Completion rate(% of total enrollments) of High income and Completion rate(% of total enrollments) of Niger?
Offer a terse response. 80.85. In the year 2005, what is the difference between the Completion rate(% of total enrollments) in High income and Completion rate(% of total enrollments) in Saudi Arabia?
Provide a short and direct response. 5.7. In the year 2005, what is the difference between the Completion rate(% of total enrollments) in Guatemala and Completion rate(% of total enrollments) in Niger?
Your answer should be very brief. 35.99. In the year 2005, what is the difference between the Completion rate(% of total enrollments) in Guatemala and Completion rate(% of total enrollments) in Saudi Arabia?
Offer a terse response. -39.17. In the year 2005, what is the difference between the Completion rate(% of total enrollments) in Niger and Completion rate(% of total enrollments) in Saudi Arabia?
Make the answer very short. -75.16. In the year 2007, what is the difference between the Completion rate(% of total enrollments) in High income and Completion rate(% of total enrollments) in Guatemala?
Your response must be concise. 39.24. In the year 2007, what is the difference between the Completion rate(% of total enrollments) of High income and Completion rate(% of total enrollments) of Niger?
Keep it short and to the point. 80.54. In the year 2007, what is the difference between the Completion rate(% of total enrollments) of High income and Completion rate(% of total enrollments) of Saudi Arabia?
Ensure brevity in your answer.  3.3. In the year 2007, what is the difference between the Completion rate(% of total enrollments) in Guatemala and Completion rate(% of total enrollments) in Niger?
Your answer should be compact. 41.3. In the year 2007, what is the difference between the Completion rate(% of total enrollments) of Guatemala and Completion rate(% of total enrollments) of Saudi Arabia?
Give a very brief answer. -35.94. In the year 2007, what is the difference between the Completion rate(% of total enrollments) of Niger and Completion rate(% of total enrollments) of Saudi Arabia?
Your answer should be compact. -77.24. In the year 2008, what is the difference between the Completion rate(% of total enrollments) of High income and Completion rate(% of total enrollments) of Guatemala?
Ensure brevity in your answer.  37.42. In the year 2008, what is the difference between the Completion rate(% of total enrollments) of High income and Completion rate(% of total enrollments) of Niger?
Your response must be concise. 79.54. In the year 2008, what is the difference between the Completion rate(% of total enrollments) of High income and Completion rate(% of total enrollments) of Saudi Arabia?
Provide a succinct answer. -0.71. In the year 2008, what is the difference between the Completion rate(% of total enrollments) of Guatemala and Completion rate(% of total enrollments) of Niger?
Offer a terse response. 42.12. In the year 2008, what is the difference between the Completion rate(% of total enrollments) in Guatemala and Completion rate(% of total enrollments) in Saudi Arabia?
Provide a succinct answer. -38.13. In the year 2008, what is the difference between the Completion rate(% of total enrollments) of Niger and Completion rate(% of total enrollments) of Saudi Arabia?
Offer a very short reply. -80.25. In the year 2010, what is the difference between the Completion rate(% of total enrollments) of High income and Completion rate(% of total enrollments) of Guatemala?
Your answer should be compact. 31.87. In the year 2010, what is the difference between the Completion rate(% of total enrollments) in High income and Completion rate(% of total enrollments) in Niger?
Give a very brief answer. 80.6. In the year 2010, what is the difference between the Completion rate(% of total enrollments) in High income and Completion rate(% of total enrollments) in Saudi Arabia?
Make the answer very short. -19.15. In the year 2010, what is the difference between the Completion rate(% of total enrollments) of Guatemala and Completion rate(% of total enrollments) of Niger?
Your response must be concise. 48.72. In the year 2010, what is the difference between the Completion rate(% of total enrollments) of Guatemala and Completion rate(% of total enrollments) of Saudi Arabia?
Provide a succinct answer. -51.02. In the year 2010, what is the difference between the Completion rate(% of total enrollments) of Niger and Completion rate(% of total enrollments) of Saudi Arabia?
Give a very brief answer. -99.75. In the year 2011, what is the difference between the Completion rate(% of total enrollments) in High income and Completion rate(% of total enrollments) in Guatemala?
Provide a succinct answer. 28.51. In the year 2011, what is the difference between the Completion rate(% of total enrollments) of High income and Completion rate(% of total enrollments) of Niger?
Provide a succinct answer. 79.32. In the year 2011, what is the difference between the Completion rate(% of total enrollments) of High income and Completion rate(% of total enrollments) of Saudi Arabia?
Offer a very short reply. -21.32. In the year 2011, what is the difference between the Completion rate(% of total enrollments) of Guatemala and Completion rate(% of total enrollments) of Niger?
Provide a short and direct response. 50.8. In the year 2011, what is the difference between the Completion rate(% of total enrollments) of Guatemala and Completion rate(% of total enrollments) of Saudi Arabia?
Provide a succinct answer. -49.84. In the year 2011, what is the difference between the Completion rate(% of total enrollments) of Niger and Completion rate(% of total enrollments) of Saudi Arabia?
Provide a succinct answer. -100.64. In the year 2012, what is the difference between the Completion rate(% of total enrollments) in High income and Completion rate(% of total enrollments) in Guatemala?
Your answer should be compact. 29.05. In the year 2012, what is the difference between the Completion rate(% of total enrollments) of High income and Completion rate(% of total enrollments) of Niger?
Provide a succinct answer. 77.61. In the year 2012, what is the difference between the Completion rate(% of total enrollments) of High income and Completion rate(% of total enrollments) of Saudi Arabia?
Your response must be concise. -20.49. In the year 2012, what is the difference between the Completion rate(% of total enrollments) in Guatemala and Completion rate(% of total enrollments) in Niger?
Give a very brief answer. 48.55. In the year 2012, what is the difference between the Completion rate(% of total enrollments) in Guatemala and Completion rate(% of total enrollments) in Saudi Arabia?
Make the answer very short. -49.54. In the year 2012, what is the difference between the Completion rate(% of total enrollments) in Niger and Completion rate(% of total enrollments) in Saudi Arabia?
Offer a very short reply. -98.09. In the year 2013, what is the difference between the Completion rate(% of total enrollments) in High income and Completion rate(% of total enrollments) in Guatemala?
Ensure brevity in your answer.  32.38. In the year 2013, what is the difference between the Completion rate(% of total enrollments) in High income and Completion rate(% of total enrollments) in Niger?
Your answer should be compact. 78.02. In the year 2013, what is the difference between the Completion rate(% of total enrollments) in High income and Completion rate(% of total enrollments) in Saudi Arabia?
Make the answer very short. -22.29. In the year 2013, what is the difference between the Completion rate(% of total enrollments) of Guatemala and Completion rate(% of total enrollments) of Niger?
Offer a very short reply. 45.65. In the year 2013, what is the difference between the Completion rate(% of total enrollments) of Guatemala and Completion rate(% of total enrollments) of Saudi Arabia?
Offer a terse response. -54.67. In the year 2013, what is the difference between the Completion rate(% of total enrollments) in Niger and Completion rate(% of total enrollments) in Saudi Arabia?
Provide a succinct answer. -100.31. What is the ratio of the Completion rate(% of total enrollments) of High income in 1979 to that in 2005?
Ensure brevity in your answer.  0.9. What is the ratio of the Completion rate(% of total enrollments) of Guatemala in 1979 to that in 2005?
Keep it short and to the point. 0.43. What is the ratio of the Completion rate(% of total enrollments) of Niger in 1979 to that in 2005?
Ensure brevity in your answer.  0.38. What is the ratio of the Completion rate(% of total enrollments) of Saudi Arabia in 1979 to that in 2005?
Keep it short and to the point. 0.32. What is the ratio of the Completion rate(% of total enrollments) of High income in 1979 to that in 2007?
Offer a very short reply. 0.9. What is the ratio of the Completion rate(% of total enrollments) of Guatemala in 1979 to that in 2007?
Offer a terse response. 0.38. What is the ratio of the Completion rate(% of total enrollments) of Niger in 1979 to that in 2007?
Offer a very short reply. 0.36. What is the ratio of the Completion rate(% of total enrollments) in Saudi Arabia in 1979 to that in 2007?
Your answer should be compact. 0.31. What is the ratio of the Completion rate(% of total enrollments) of High income in 1979 to that in 2008?
Your answer should be very brief. 0.89. What is the ratio of the Completion rate(% of total enrollments) of Guatemala in 1979 to that in 2008?
Provide a succinct answer. 0.36. What is the ratio of the Completion rate(% of total enrollments) in Niger in 1979 to that in 2008?
Offer a terse response. 0.31. What is the ratio of the Completion rate(% of total enrollments) of Saudi Arabia in 1979 to that in 2008?
Ensure brevity in your answer.  0.3. What is the ratio of the Completion rate(% of total enrollments) in High income in 1979 to that in 2010?
Make the answer very short. 0.88. What is the ratio of the Completion rate(% of total enrollments) in Guatemala in 1979 to that in 2010?
Give a very brief answer. 0.32. What is the ratio of the Completion rate(% of total enrollments) in Niger in 1979 to that in 2010?
Keep it short and to the point. 0.31. What is the ratio of the Completion rate(% of total enrollments) of Saudi Arabia in 1979 to that in 2010?
Keep it short and to the point. 0.25. What is the ratio of the Completion rate(% of total enrollments) of High income in 1979 to that in 2011?
Your response must be concise. 0.88. What is the ratio of the Completion rate(% of total enrollments) of Guatemala in 1979 to that in 2011?
Your response must be concise. 0.3. What is the ratio of the Completion rate(% of total enrollments) in Niger in 1979 to that in 2011?
Make the answer very short. 0.27. What is the ratio of the Completion rate(% of total enrollments) of Saudi Arabia in 1979 to that in 2011?
Your answer should be very brief. 0.24. What is the ratio of the Completion rate(% of total enrollments) of High income in 1979 to that in 2012?
Give a very brief answer. 0.88. What is the ratio of the Completion rate(% of total enrollments) in Guatemala in 1979 to that in 2012?
Give a very brief answer. 0.3. What is the ratio of the Completion rate(% of total enrollments) of Niger in 1979 to that in 2012?
Provide a succinct answer. 0.23. What is the ratio of the Completion rate(% of total enrollments) of Saudi Arabia in 1979 to that in 2012?
Make the answer very short. 0.24. What is the ratio of the Completion rate(% of total enrollments) of High income in 1979 to that in 2013?
Your answer should be very brief. 0.87. What is the ratio of the Completion rate(% of total enrollments) of Guatemala in 1979 to that in 2013?
Provide a succinct answer. 0.32. What is the ratio of the Completion rate(% of total enrollments) of Niger in 1979 to that in 2013?
Your response must be concise. 0.22. What is the ratio of the Completion rate(% of total enrollments) of Saudi Arabia in 1979 to that in 2013?
Your answer should be compact. 0.24. What is the ratio of the Completion rate(% of total enrollments) in High income in 2005 to that in 2007?
Give a very brief answer. 1. What is the ratio of the Completion rate(% of total enrollments) in Guatemala in 2005 to that in 2007?
Your answer should be compact. 0.88. What is the ratio of the Completion rate(% of total enrollments) of Niger in 2005 to that in 2007?
Provide a short and direct response. 0.93. What is the ratio of the Completion rate(% of total enrollments) of Saudi Arabia in 2005 to that in 2007?
Offer a very short reply. 0.97. What is the ratio of the Completion rate(% of total enrollments) in Guatemala in 2005 to that in 2008?
Ensure brevity in your answer.  0.84. What is the ratio of the Completion rate(% of total enrollments) in Niger in 2005 to that in 2008?
Offer a very short reply. 0.8. What is the ratio of the Completion rate(% of total enrollments) in Saudi Arabia in 2005 to that in 2008?
Make the answer very short. 0.92. What is the ratio of the Completion rate(% of total enrollments) of High income in 2005 to that in 2010?
Your answer should be compact. 0.98. What is the ratio of the Completion rate(% of total enrollments) in Guatemala in 2005 to that in 2010?
Make the answer very short. 0.75. What is the ratio of the Completion rate(% of total enrollments) of Niger in 2005 to that in 2010?
Provide a short and direct response. 0.81. What is the ratio of the Completion rate(% of total enrollments) in Saudi Arabia in 2005 to that in 2010?
Provide a short and direct response. 0.76. What is the ratio of the Completion rate(% of total enrollments) in High income in 2005 to that in 2011?
Provide a succinct answer. 0.98. What is the ratio of the Completion rate(% of total enrollments) of Guatemala in 2005 to that in 2011?
Offer a terse response. 0.71. What is the ratio of the Completion rate(% of total enrollments) of Niger in 2005 to that in 2011?
Offer a terse response. 0.7. What is the ratio of the Completion rate(% of total enrollments) in Saudi Arabia in 2005 to that in 2011?
Ensure brevity in your answer.  0.74. What is the ratio of the Completion rate(% of total enrollments) in Guatemala in 2005 to that in 2012?
Your response must be concise. 0.71. What is the ratio of the Completion rate(% of total enrollments) of Niger in 2005 to that in 2012?
Offer a very short reply. 0.61. What is the ratio of the Completion rate(% of total enrollments) in Saudi Arabia in 2005 to that in 2012?
Make the answer very short. 0.75. What is the ratio of the Completion rate(% of total enrollments) of High income in 2005 to that in 2013?
Your answer should be very brief. 0.97. What is the ratio of the Completion rate(% of total enrollments) in Guatemala in 2005 to that in 2013?
Provide a short and direct response. 0.74. What is the ratio of the Completion rate(% of total enrollments) of Niger in 2005 to that in 2013?
Keep it short and to the point. 0.58. What is the ratio of the Completion rate(% of total enrollments) in Saudi Arabia in 2005 to that in 2013?
Ensure brevity in your answer.  0.73. What is the ratio of the Completion rate(% of total enrollments) of High income in 2007 to that in 2008?
Offer a very short reply. 1. What is the ratio of the Completion rate(% of total enrollments) of Guatemala in 2007 to that in 2008?
Give a very brief answer. 0.96. What is the ratio of the Completion rate(% of total enrollments) in Niger in 2007 to that in 2008?
Give a very brief answer. 0.86. What is the ratio of the Completion rate(% of total enrollments) in Saudi Arabia in 2007 to that in 2008?
Ensure brevity in your answer.  0.95. What is the ratio of the Completion rate(% of total enrollments) of High income in 2007 to that in 2010?
Offer a terse response. 0.99. What is the ratio of the Completion rate(% of total enrollments) in Guatemala in 2007 to that in 2010?
Offer a terse response. 0.85. What is the ratio of the Completion rate(% of total enrollments) in Niger in 2007 to that in 2010?
Your answer should be very brief. 0.86. What is the ratio of the Completion rate(% of total enrollments) of Saudi Arabia in 2007 to that in 2010?
Your answer should be compact. 0.78. What is the ratio of the Completion rate(% of total enrollments) of High income in 2007 to that in 2011?
Make the answer very short. 0.98. What is the ratio of the Completion rate(% of total enrollments) in Guatemala in 2007 to that in 2011?
Offer a terse response. 0.8. What is the ratio of the Completion rate(% of total enrollments) in Niger in 2007 to that in 2011?
Provide a succinct answer. 0.75. What is the ratio of the Completion rate(% of total enrollments) of Saudi Arabia in 2007 to that in 2011?
Keep it short and to the point. 0.77. What is the ratio of the Completion rate(% of total enrollments) of High income in 2007 to that in 2012?
Provide a short and direct response. 0.99. What is the ratio of the Completion rate(% of total enrollments) in Guatemala in 2007 to that in 2012?
Offer a terse response. 0.81. What is the ratio of the Completion rate(% of total enrollments) in Niger in 2007 to that in 2012?
Make the answer very short. 0.65. What is the ratio of the Completion rate(% of total enrollments) in Saudi Arabia in 2007 to that in 2012?
Give a very brief answer. 0.77. What is the ratio of the Completion rate(% of total enrollments) of High income in 2007 to that in 2013?
Ensure brevity in your answer.  0.98. What is the ratio of the Completion rate(% of total enrollments) in Guatemala in 2007 to that in 2013?
Keep it short and to the point. 0.84. What is the ratio of the Completion rate(% of total enrollments) in Niger in 2007 to that in 2013?
Your answer should be compact. 0.63. What is the ratio of the Completion rate(% of total enrollments) of Saudi Arabia in 2007 to that in 2013?
Give a very brief answer. 0.75. What is the ratio of the Completion rate(% of total enrollments) of Guatemala in 2008 to that in 2010?
Your response must be concise. 0.89. What is the ratio of the Completion rate(% of total enrollments) in Saudi Arabia in 2008 to that in 2010?
Offer a very short reply. 0.82. What is the ratio of the Completion rate(% of total enrollments) of Guatemala in 2008 to that in 2011?
Provide a succinct answer. 0.84. What is the ratio of the Completion rate(% of total enrollments) in Niger in 2008 to that in 2011?
Your answer should be compact. 0.88. What is the ratio of the Completion rate(% of total enrollments) in Saudi Arabia in 2008 to that in 2011?
Provide a succinct answer. 0.8. What is the ratio of the Completion rate(% of total enrollments) in High income in 2008 to that in 2012?
Provide a succinct answer. 0.99. What is the ratio of the Completion rate(% of total enrollments) in Guatemala in 2008 to that in 2012?
Provide a short and direct response. 0.85. What is the ratio of the Completion rate(% of total enrollments) of Niger in 2008 to that in 2012?
Keep it short and to the point. 0.76. What is the ratio of the Completion rate(% of total enrollments) in Saudi Arabia in 2008 to that in 2012?
Make the answer very short. 0.81. What is the ratio of the Completion rate(% of total enrollments) of High income in 2008 to that in 2013?
Give a very brief answer. 0.98. What is the ratio of the Completion rate(% of total enrollments) of Guatemala in 2008 to that in 2013?
Offer a terse response. 0.88. What is the ratio of the Completion rate(% of total enrollments) of Niger in 2008 to that in 2013?
Keep it short and to the point. 0.73. What is the ratio of the Completion rate(% of total enrollments) in Saudi Arabia in 2008 to that in 2013?
Offer a terse response. 0.79. What is the ratio of the Completion rate(% of total enrollments) in High income in 2010 to that in 2011?
Your answer should be very brief. 1. What is the ratio of the Completion rate(% of total enrollments) of Guatemala in 2010 to that in 2011?
Give a very brief answer. 0.94. What is the ratio of the Completion rate(% of total enrollments) of Niger in 2010 to that in 2011?
Offer a terse response. 0.87. What is the ratio of the Completion rate(% of total enrollments) in Saudi Arabia in 2010 to that in 2011?
Your response must be concise. 0.98. What is the ratio of the Completion rate(% of total enrollments) of High income in 2010 to that in 2012?
Make the answer very short. 1. What is the ratio of the Completion rate(% of total enrollments) of Guatemala in 2010 to that in 2012?
Your answer should be very brief. 0.95. What is the ratio of the Completion rate(% of total enrollments) in Niger in 2010 to that in 2012?
Your answer should be compact. 0.76. What is the ratio of the Completion rate(% of total enrollments) of High income in 2010 to that in 2013?
Ensure brevity in your answer.  0.99. What is the ratio of the Completion rate(% of total enrollments) in Niger in 2010 to that in 2013?
Give a very brief answer. 0.72. What is the ratio of the Completion rate(% of total enrollments) of Guatemala in 2011 to that in 2012?
Provide a succinct answer. 1.01. What is the ratio of the Completion rate(% of total enrollments) in Niger in 2011 to that in 2012?
Keep it short and to the point. 0.87. What is the ratio of the Completion rate(% of total enrollments) in Saudi Arabia in 2011 to that in 2012?
Offer a very short reply. 1.01. What is the ratio of the Completion rate(% of total enrollments) of High income in 2011 to that in 2013?
Your response must be concise. 0.99. What is the ratio of the Completion rate(% of total enrollments) of Guatemala in 2011 to that in 2013?
Provide a succinct answer. 1.05. What is the ratio of the Completion rate(% of total enrollments) of Niger in 2011 to that in 2013?
Offer a very short reply. 0.83. What is the ratio of the Completion rate(% of total enrollments) of Saudi Arabia in 2011 to that in 2013?
Offer a terse response. 0.98. What is the ratio of the Completion rate(% of total enrollments) of High income in 2012 to that in 2013?
Offer a terse response. 0.99. What is the ratio of the Completion rate(% of total enrollments) in Guatemala in 2012 to that in 2013?
Offer a terse response. 1.04. What is the ratio of the Completion rate(% of total enrollments) of Niger in 2012 to that in 2013?
Offer a very short reply. 0.96. What is the ratio of the Completion rate(% of total enrollments) in Saudi Arabia in 2012 to that in 2013?
Make the answer very short. 0.98. What is the difference between the highest and the second highest Completion rate(% of total enrollments) in High income?
Your answer should be very brief. 0.83. What is the difference between the highest and the second highest Completion rate(% of total enrollments) of Guatemala?
Make the answer very short. 0.64. What is the difference between the highest and the second highest Completion rate(% of total enrollments) of Niger?
Your answer should be compact. 0.52. What is the difference between the highest and the second highest Completion rate(% of total enrollments) of Saudi Arabia?
Offer a terse response. 1.8. What is the difference between the highest and the lowest Completion rate(% of total enrollments) of High income?
Offer a very short reply. 11.53. What is the difference between the highest and the lowest Completion rate(% of total enrollments) in Guatemala?
Keep it short and to the point. 42.93. What is the difference between the highest and the lowest Completion rate(% of total enrollments) of Niger?
Make the answer very short. 9.88. What is the difference between the highest and the lowest Completion rate(% of total enrollments) in Saudi Arabia?
Your answer should be compact. 86.28. 